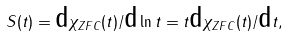Convert formula to latex. <formula><loc_0><loc_0><loc_500><loc_500>S ( t ) = \text {d} \chi _ { Z F C } ( t ) / \text {d} \ln t = t \text {d} \chi _ { Z F C } ( t ) / \text {d} t ,</formula> 